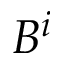<formula> <loc_0><loc_0><loc_500><loc_500>B ^ { i }</formula> 